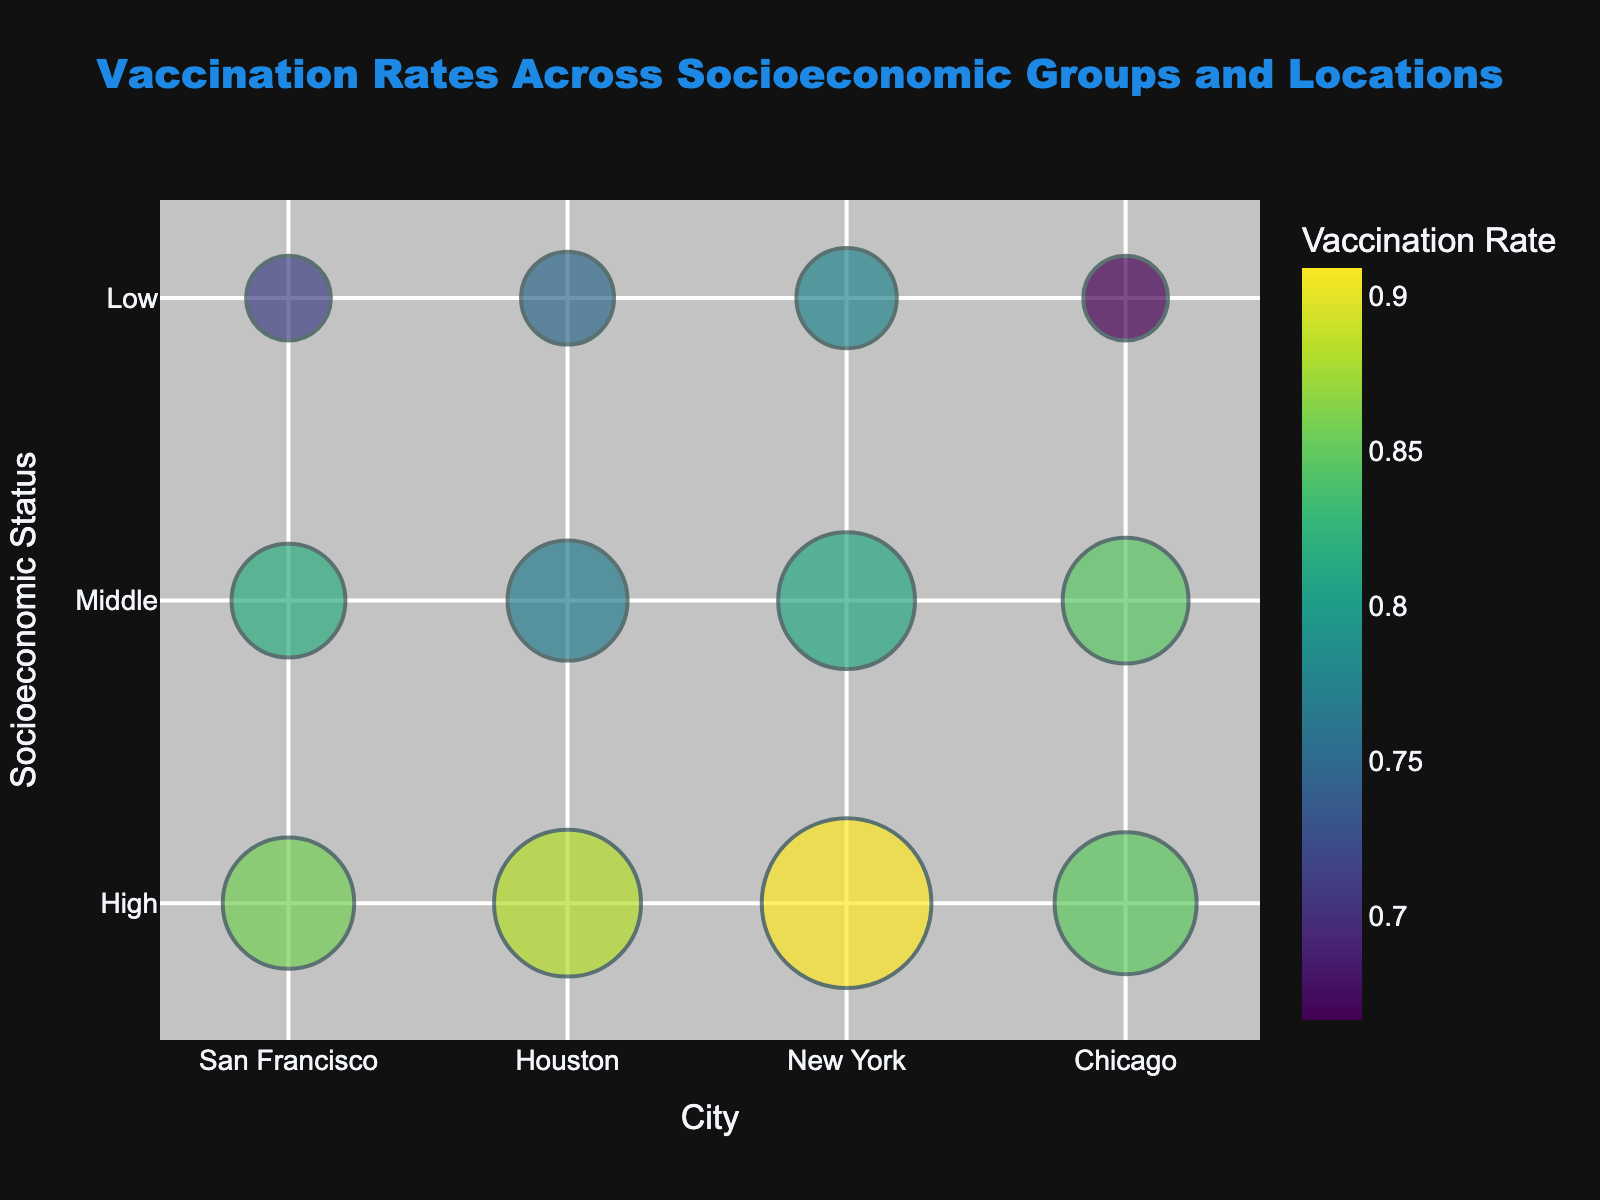What is the title of the bubble chart? The title of a chart is typically displayed at the top and is intended to provide a concise summary of what the chart represents. In this bubble chart, it reads "Vaccination Rates Across Socioeconomic Groups and Locations."
Answer: Vaccination Rates Across Socioeconomic Groups and Locations Which city has the highest vaccination rate for high-income groups? The vaccination rate is depicted through colors, with darker shades typically signifying higher rates. By examining the high-income group within each city, we identify that New York has the darkest color, which signifies the highest rate.
Answer: New York How does the vaccination rate compare between middle-income groups in San Francisco and Houston? To compare the vaccination rates between two groups, we look at their color shades. Middle-income group in Houston has a darker shade indicating a higher vaccination rate compared to San Francisco.
Answer: Houston has a higher rate How many cities are represented in this bubble chart? Each unique position along the x-axis represents a different city, and the x-axis labels should be checked to count the distinct cities. The cities represented are San Francisco, Houston, New York, and Chicago.
Answer: 4 What is the relationship between the size of the bubbles and the number of vaccinations? The size of the bubbles represents the number of vaccinations, where larger bubbles indicate a higher number of vaccinations. This is a primary feature in the bubble chart.
Answer: Larger bubbles signify a higher number of vaccinations Which socio-economic group in San Francisco has the smallest number of vaccinations? The bubble sizes across different socio-economic groups in San Francisco need to be examined. The smallest bubble in San Francisco belongs to the low-income group.
Answer: Low-income group What is the total number of vaccinations in New York across all socio-economic groups? Adding the number of vaccinations for high, middle, and low-income groups in New York: 20000 (high) + 13000 (middle) + 7000 (low) equals a total of 40000 vaccinations.
Answer: 40000 How does the vaccination rate for low-income groups in Houston compare to that in Chicago? Compare the color shades of the low-income group bubbles in Houston and Chicago. Houston’s low-income group has a darker shade, indicating a higher vaccination rate than Chicago’s.
Answer: Houston has a higher rate Which socio-economic group in Chicago has the highest vaccination rate? By observing the coloration of bubbles representing Chicago’s socio-economic groups, the high-income group has the darkest shade, indicating the highest vaccination rate.
Answer: High-income group What is the average population size across all socio-economic groups in New York? Adding the population sizes for high, middle, and low-income groups in New York: 22000 (high) + 16000 (middle) + 9000 (low) gives 47000. Dividing by 3 for an average, we get 47000 / 3 ≈ 15667.
Answer: 15667 